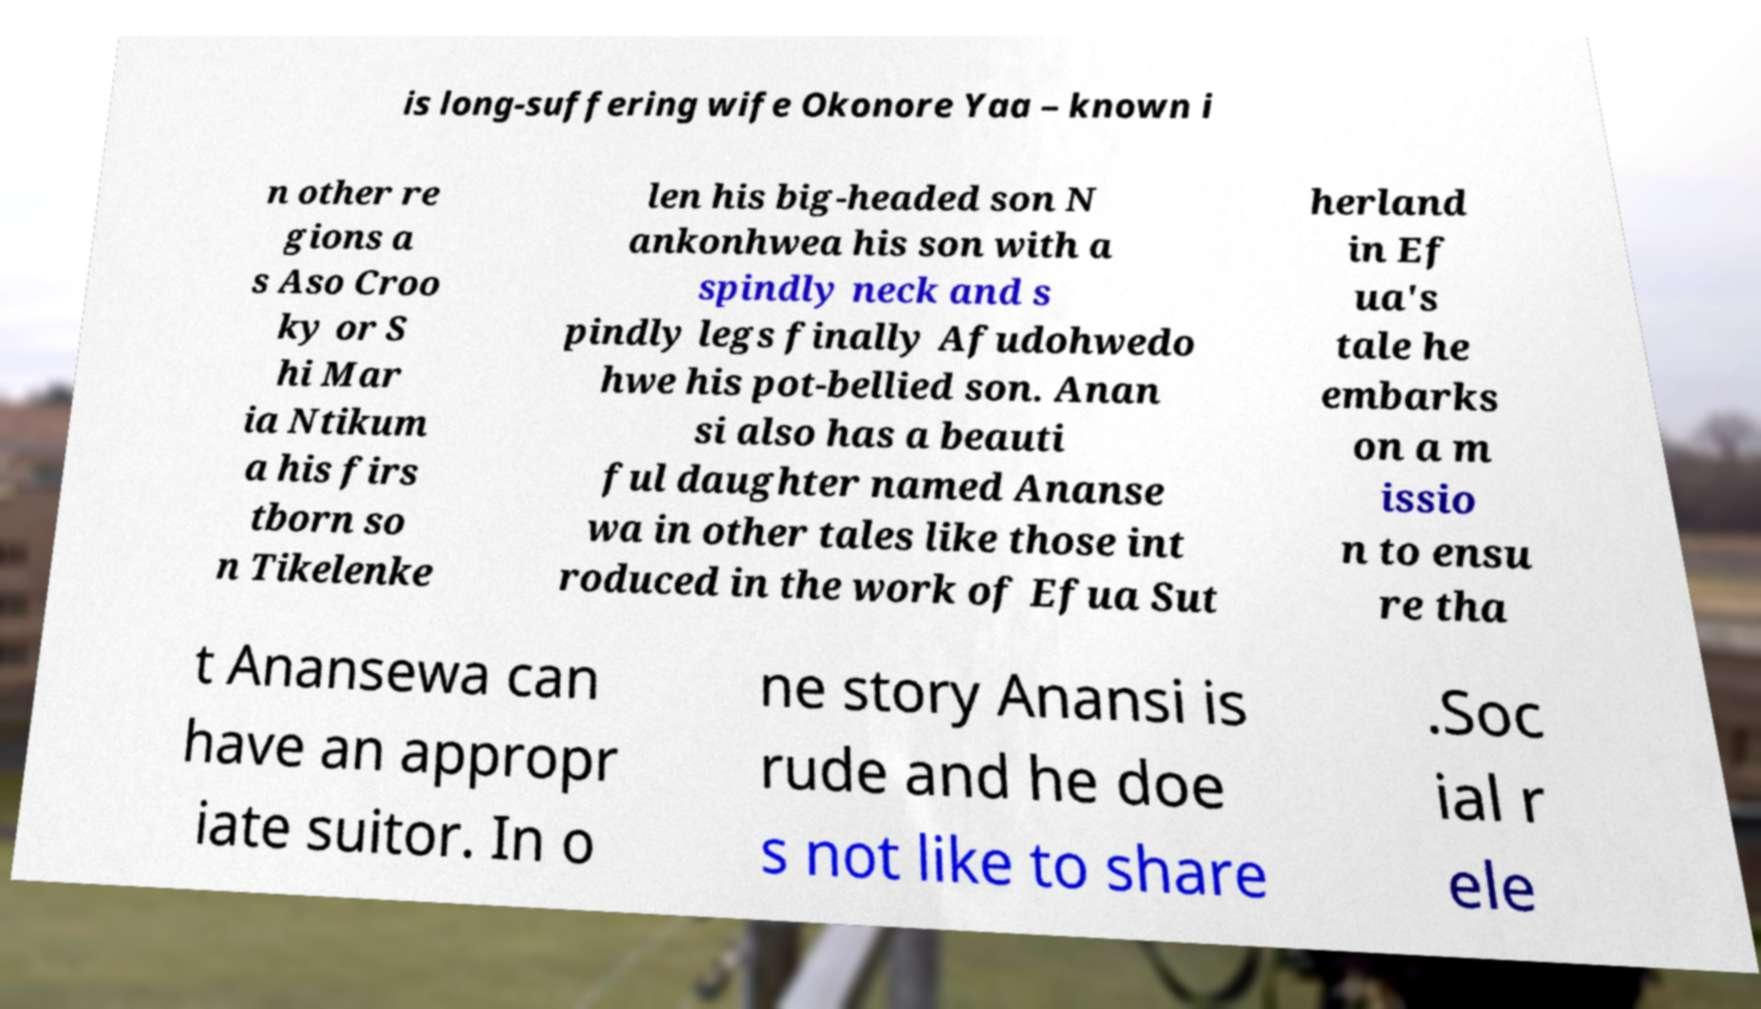Can you accurately transcribe the text from the provided image for me? is long-suffering wife Okonore Yaa – known i n other re gions a s Aso Croo ky or S hi Mar ia Ntikum a his firs tborn so n Tikelenke len his big-headed son N ankonhwea his son with a spindly neck and s pindly legs finally Afudohwedo hwe his pot-bellied son. Anan si also has a beauti ful daughter named Ananse wa in other tales like those int roduced in the work of Efua Sut herland in Ef ua's tale he embarks on a m issio n to ensu re tha t Anansewa can have an appropr iate suitor. In o ne story Anansi is rude and he doe s not like to share .Soc ial r ele 